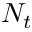<formula> <loc_0><loc_0><loc_500><loc_500>N _ { t }</formula> 